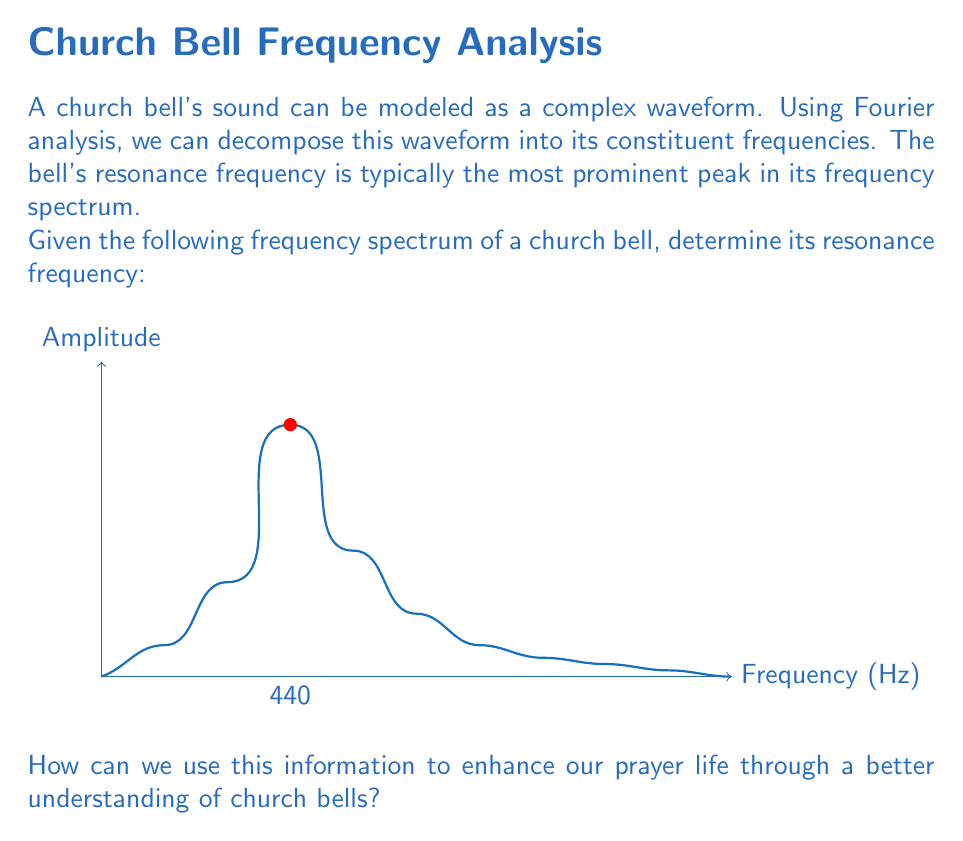Could you help me with this problem? To solve this problem, we'll follow these steps:

1) Recall that in Fourier analysis, the frequency spectrum represents the amplitude of each frequency component in the original signal.

2) The resonance frequency of the bell corresponds to the frequency with the highest amplitude in the spectrum.

3) Examining the given frequency spectrum:
   
   $$f(x) = \sum_{n=1}^{\infty} A_n \sin(2\pi f_n x)$$
   
   Where $A_n$ represents the amplitude and $f_n$ the frequency of each component.

4) We can see that the highest peak occurs at 440 Hz.

5) Therefore, the resonance frequency of the church bell is 440 Hz.

From a spiritual perspective, understanding the resonance frequency of church bells can deepen our appreciation for the role of sound in worship. The resonant tone at 440 Hz, which corresponds to the musical note A4, can be seen as a call to prayer, reminding us of God's presence and inviting us into a state of reverence and contemplation.

This frequency analysis also illustrates how complex and beautiful even a simple church bell can be, reflecting the intricate nature of God's creation. Just as we can break down the sound of a bell into its component frequencies, we can approach prayer by examining the different aspects of our relationship with God.
Answer: 440 Hz 